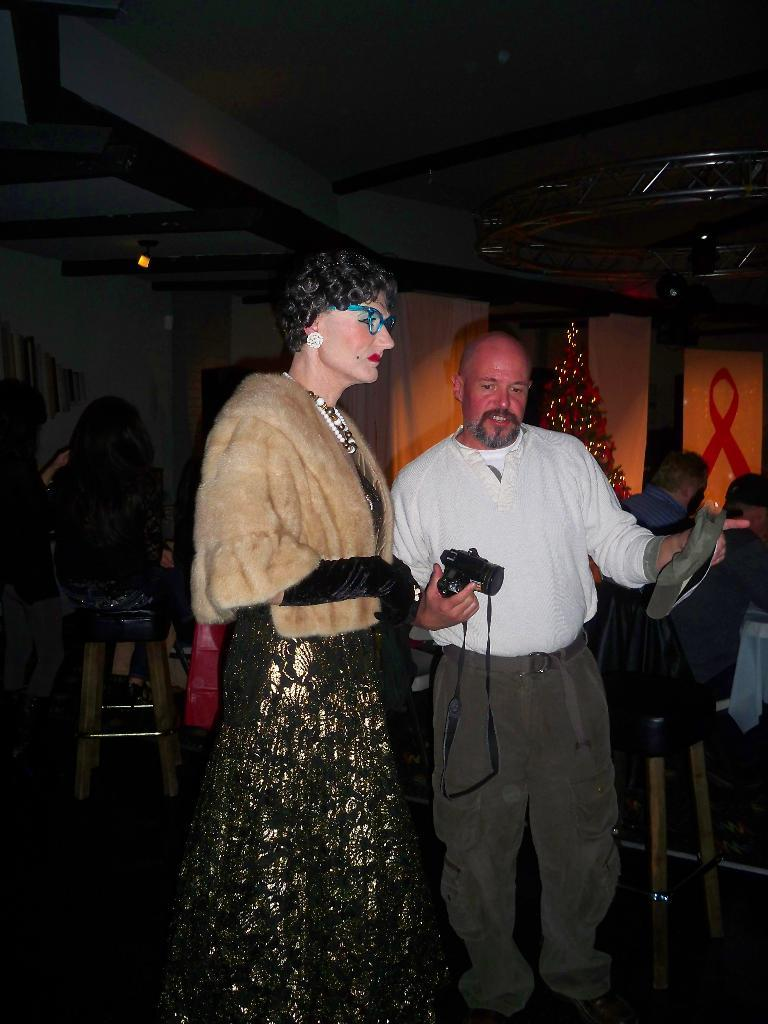How many people are in the center of the image? There are two people standing in the center of the image. What can be seen in the background of the image? There is a stool, other persons, a wall, and a Christmas tree in the background of the image. What type of produce can be seen on the scale in the image? There is no scale or produce present in the image. What does the Christmas tree smell like in the image? The image does not provide information about the smell of the Christmas tree. 